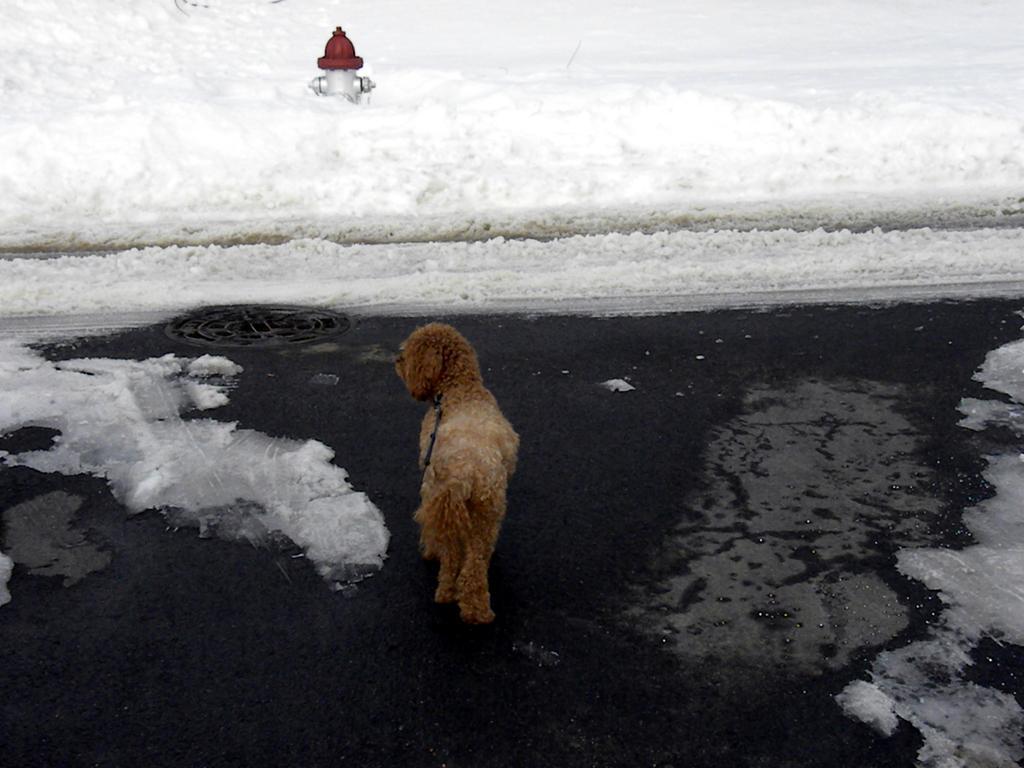In one or two sentences, can you explain what this image depicts? In this picture I can see a dog in front, which is of brown and white color and it is on the black and white color surface. In the background I can see the snow and I can see a fire hydrant in the middle and it is of white and red color. 